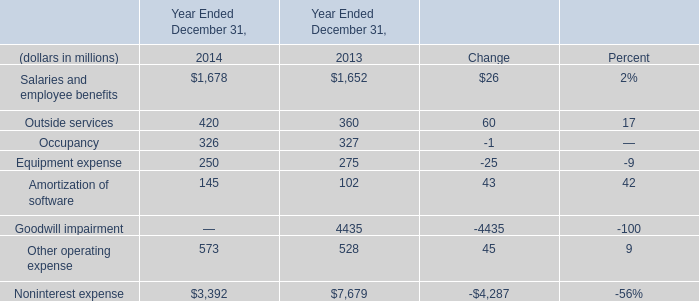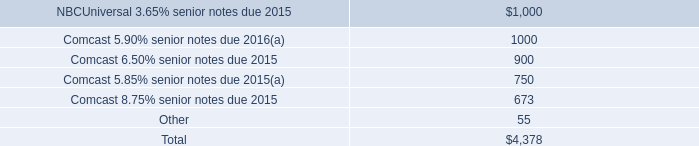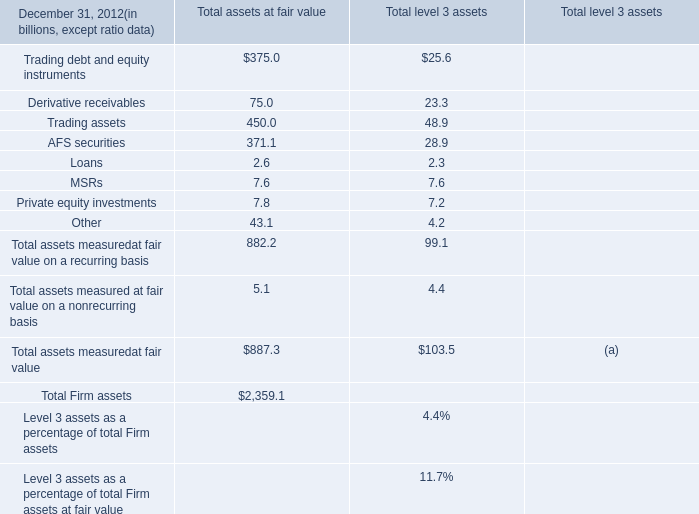what was the percent of the net of amounts out- standing under our commercial paper programs and outstanding letters of credit associated with the nbcuniversal enterprise revolving credit facility 
Computations: (775 / 6.4)
Answer: 121.09375. 